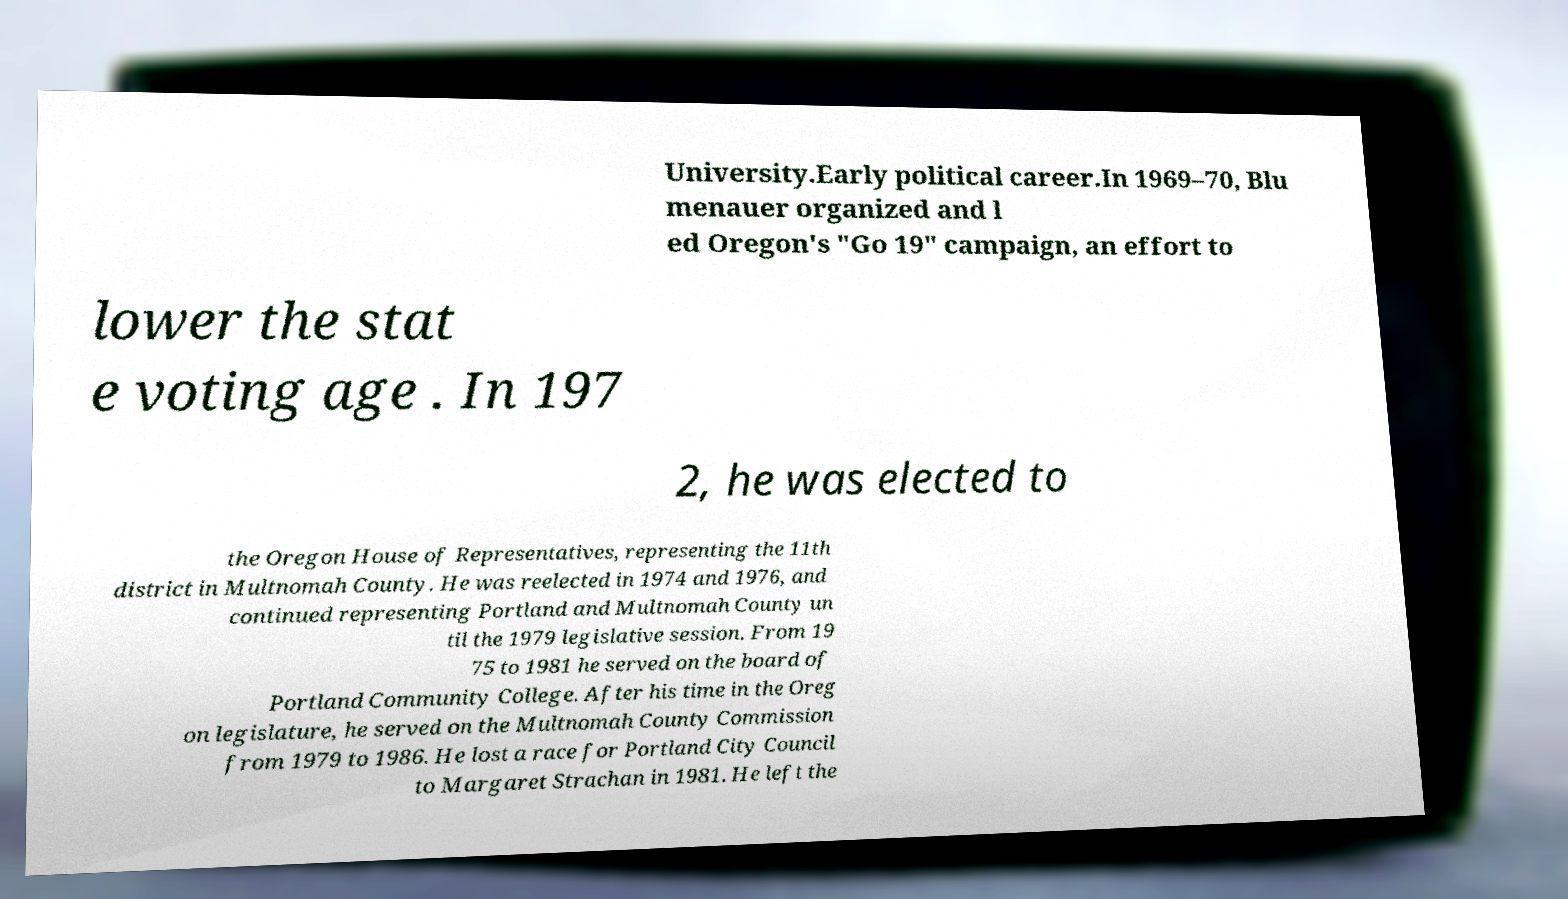There's text embedded in this image that I need extracted. Can you transcribe it verbatim? University.Early political career.In 1969–70, Blu menauer organized and l ed Oregon's "Go 19" campaign, an effort to lower the stat e voting age . In 197 2, he was elected to the Oregon House of Representatives, representing the 11th district in Multnomah County. He was reelected in 1974 and 1976, and continued representing Portland and Multnomah County un til the 1979 legislative session. From 19 75 to 1981 he served on the board of Portland Community College. After his time in the Oreg on legislature, he served on the Multnomah County Commission from 1979 to 1986. He lost a race for Portland City Council to Margaret Strachan in 1981. He left the 